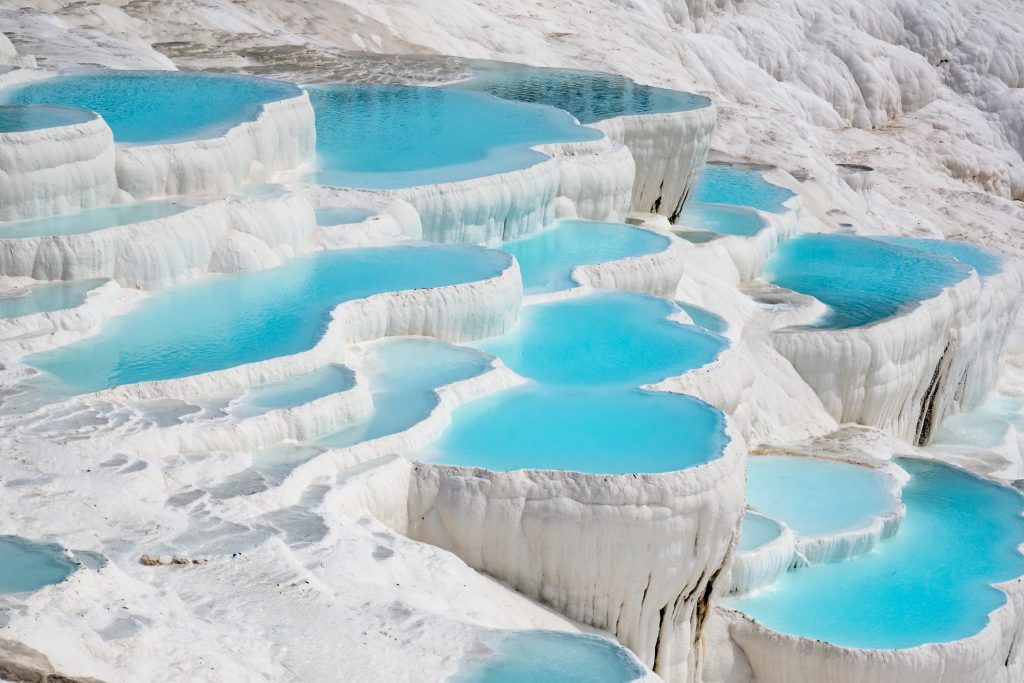Can you elaborate on the elements of the picture provided? This image captures the stunning natural wonder known as Pamukkale, located in Turkey. The vibrant blue water of the thermal pools contrasts sharply with the pristine white travertine terraces. These terraces are formed by mineral deposits, predominantly calcium carbonate, left behind by the flowing water from nearby hot springs. The photograph provides an aerial view, giving a comprehensive perspective of the terraces and their intricate formations. The terraces resemble cascading layers of cotton, which is why the site is named 'Pamukkale', meaning 'Cotton Castle' in Turkish. As a UNESCO World Heritage site, Pamukkale is not just a feast for the eyes but also a significant geological and historical landmark, encapsulating natural beauty and grandeur in one frame. 